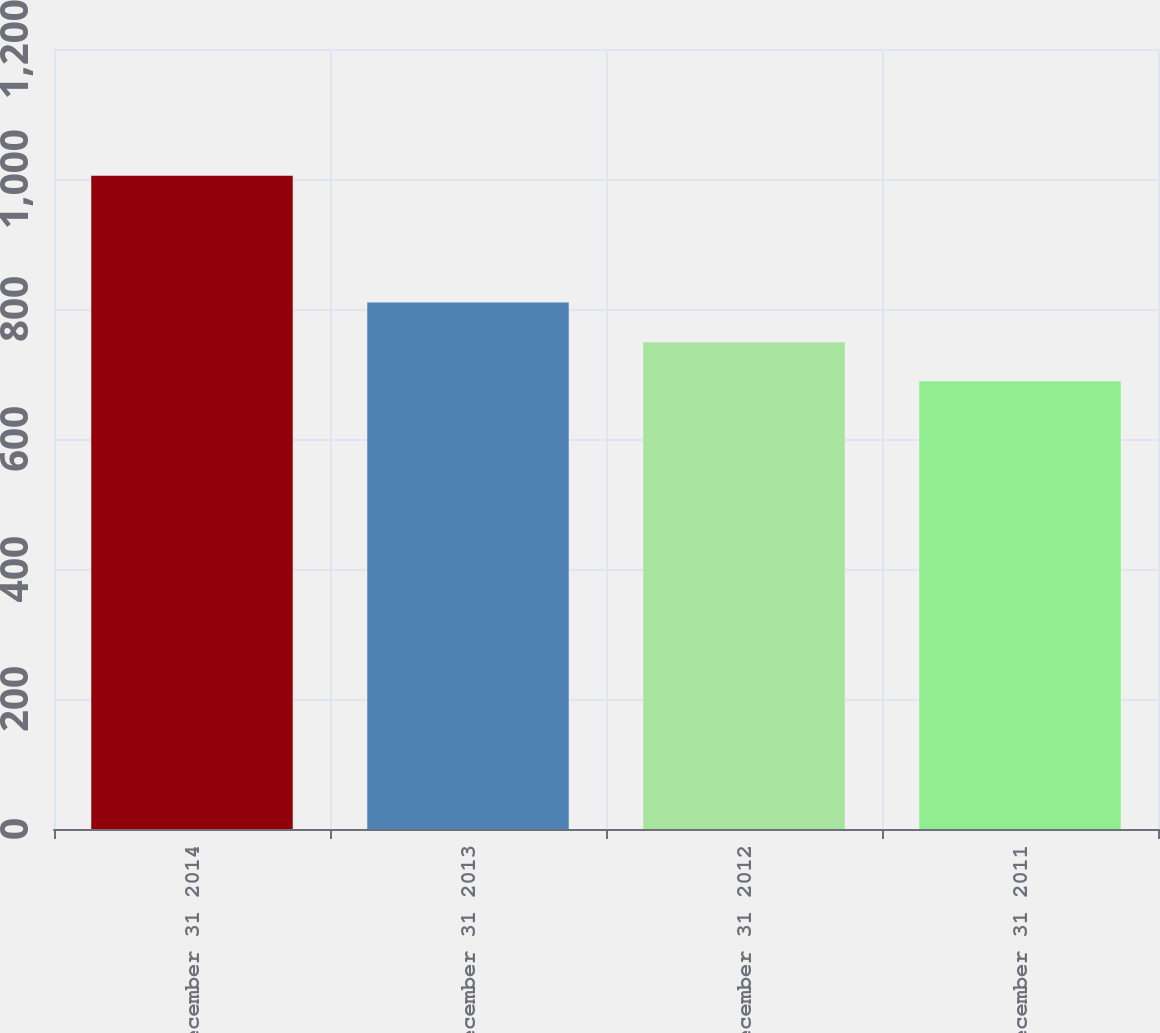<chart> <loc_0><loc_0><loc_500><loc_500><bar_chart><fcel>December 31 2014<fcel>December 31 2013<fcel>December 31 2012<fcel>December 31 2011<nl><fcel>1005<fcel>810<fcel>749<fcel>689<nl></chart> 